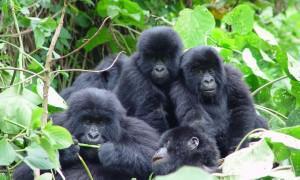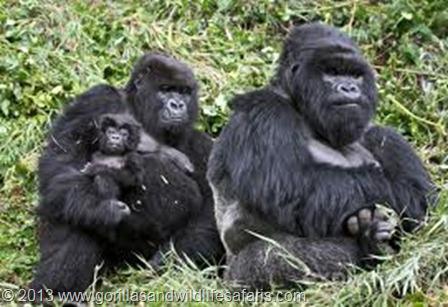The first image is the image on the left, the second image is the image on the right. Given the left and right images, does the statement "The image on the right shows at least one baby gorilla atop an adult gorilla that is not facing the camera." hold true? Answer yes or no. No. The first image is the image on the left, the second image is the image on the right. Considering the images on both sides, is "Atleast 3 animals in every picture." valid? Answer yes or no. Yes. 